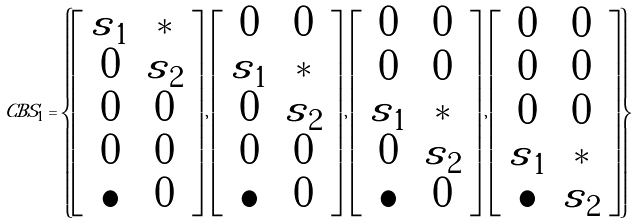<formula> <loc_0><loc_0><loc_500><loc_500>C B S _ { 1 } = \left \{ \left [ \begin{array} { c c } { \tilde { s } } _ { 1 } & * \\ 0 & { \tilde { s } } _ { 2 } \\ 0 & 0 \\ 0 & 0 \\ \bullet & 0 \end{array} \right ] , \left [ \begin{array} { c c } 0 & 0 \\ { \tilde { s } } _ { 1 } & * \\ 0 & { \tilde { s } } _ { 2 } \\ 0 & 0 \\ \bullet & 0 \end{array} \right ] , \left [ \begin{array} { c c } 0 & 0 \\ 0 & 0 \\ { \tilde { s } } _ { 1 } & * \\ 0 & { \tilde { s } } _ { 2 } \\ \bullet & 0 \end{array} \right ] , \left [ \begin{array} { c c } 0 & 0 \\ 0 & 0 \\ 0 & 0 \\ { \tilde { s } } _ { 1 } & * \\ \bullet & { \tilde { s } } _ { 2 } \end{array} \right ] \right \}</formula> 